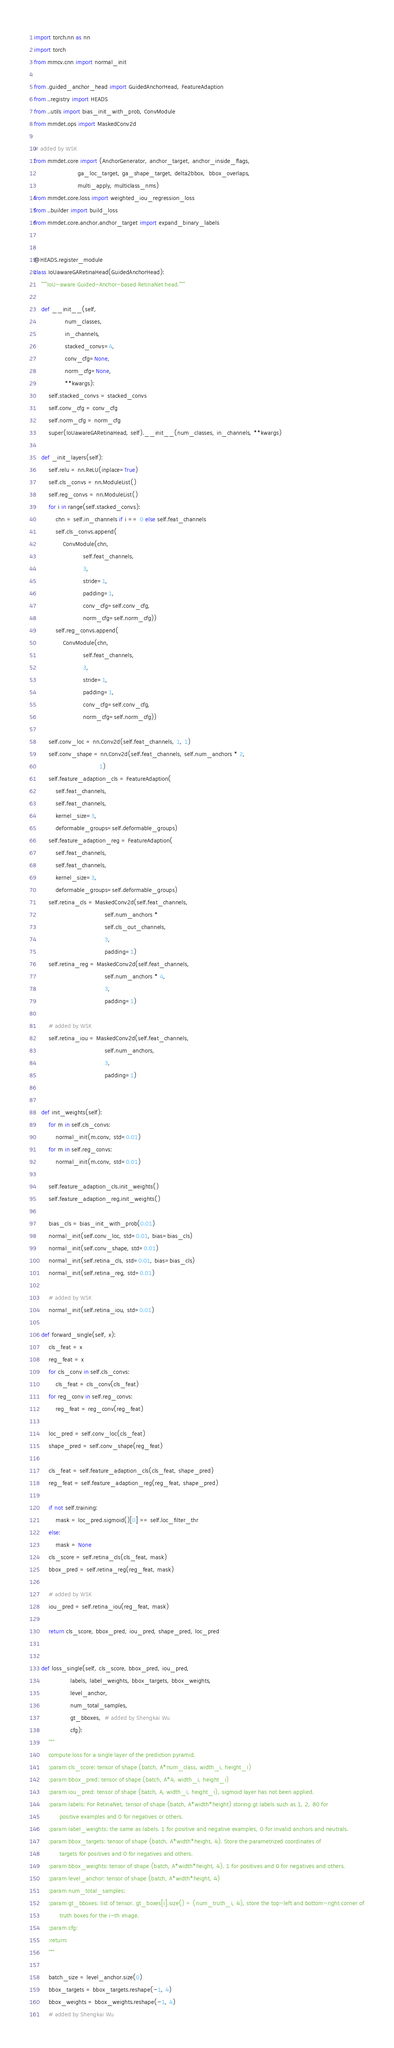<code> <loc_0><loc_0><loc_500><loc_500><_Python_>import torch.nn as nn
import torch
from mmcv.cnn import normal_init

from .guided_anchor_head import GuidedAnchorHead, FeatureAdaption
from ..registry import HEADS
from ..utils import bias_init_with_prob, ConvModule
from mmdet.ops import MaskedConv2d

# added by WSK
from mmdet.core import (AnchorGenerator, anchor_target, anchor_inside_flags,
                        ga_loc_target, ga_shape_target, delta2bbox,  bbox_overlaps,
                        multi_apply, multiclass_nms)
from mmdet.core.loss import weighted_iou_regression_loss
from ..builder import build_loss
from mmdet.core.anchor.anchor_target import expand_binary_labels


@HEADS.register_module
class IoUawareGARetinaHead(GuidedAnchorHead):
    """IoU-aware Guided-Anchor-based RetinaNet head."""

    def __init__(self,
                 num_classes,
                 in_channels,
                 stacked_convs=4,
                 conv_cfg=None,
                 norm_cfg=None,
                 **kwargs):
        self.stacked_convs = stacked_convs
        self.conv_cfg = conv_cfg
        self.norm_cfg = norm_cfg
        super(IoUawareGARetinaHead, self).__init__(num_classes, in_channels, **kwargs)

    def _init_layers(self):
        self.relu = nn.ReLU(inplace=True)
        self.cls_convs = nn.ModuleList()
        self.reg_convs = nn.ModuleList()
        for i in range(self.stacked_convs):
            chn = self.in_channels if i == 0 else self.feat_channels
            self.cls_convs.append(
                ConvModule(chn,
                           self.feat_channels,
                           3,
                           stride=1,
                           padding=1,
                           conv_cfg=self.conv_cfg,
                           norm_cfg=self.norm_cfg))
            self.reg_convs.append(
                ConvModule(chn,
                           self.feat_channels,
                           3,
                           stride=1,
                           padding=1,
                           conv_cfg=self.conv_cfg,
                           norm_cfg=self.norm_cfg))

        self.conv_loc = nn.Conv2d(self.feat_channels, 1, 1)
        self.conv_shape = nn.Conv2d(self.feat_channels, self.num_anchors * 2,
                                    1)
        self.feature_adaption_cls = FeatureAdaption(
            self.feat_channels,
            self.feat_channels,
            kernel_size=3,
            deformable_groups=self.deformable_groups)
        self.feature_adaption_reg = FeatureAdaption(
            self.feat_channels,
            self.feat_channels,
            kernel_size=3,
            deformable_groups=self.deformable_groups)
        self.retina_cls = MaskedConv2d(self.feat_channels,
                                       self.num_anchors *
                                       self.cls_out_channels,
                                       3,
                                       padding=1)
        self.retina_reg = MaskedConv2d(self.feat_channels,
                                       self.num_anchors * 4,
                                       3,
                                       padding=1)

        # added by WSK
        self.retina_iou = MaskedConv2d(self.feat_channels,
                                       self.num_anchors,
                                       3,
                                       padding=1)


    def init_weights(self):
        for m in self.cls_convs:
            normal_init(m.conv, std=0.01)
        for m in self.reg_convs:
            normal_init(m.conv, std=0.01)

        self.feature_adaption_cls.init_weights()
        self.feature_adaption_reg.init_weights()

        bias_cls = bias_init_with_prob(0.01)
        normal_init(self.conv_loc, std=0.01, bias=bias_cls)
        normal_init(self.conv_shape, std=0.01)
        normal_init(self.retina_cls, std=0.01, bias=bias_cls)
        normal_init(self.retina_reg, std=0.01)

        # added by WSK
        normal_init(self.retina_iou, std=0.01)

    def forward_single(self, x):
        cls_feat = x
        reg_feat = x
        for cls_conv in self.cls_convs:
            cls_feat = cls_conv(cls_feat)
        for reg_conv in self.reg_convs:
            reg_feat = reg_conv(reg_feat)

        loc_pred = self.conv_loc(cls_feat)
        shape_pred = self.conv_shape(reg_feat)

        cls_feat = self.feature_adaption_cls(cls_feat, shape_pred)
        reg_feat = self.feature_adaption_reg(reg_feat, shape_pred)

        if not self.training:
            mask = loc_pred.sigmoid()[0] >= self.loc_filter_thr
        else:
            mask = None
        cls_score = self.retina_cls(cls_feat, mask)
        bbox_pred = self.retina_reg(reg_feat, mask)

        # added by WSK
        iou_pred = self.retina_iou(reg_feat, mask)

        return cls_score, bbox_pred, iou_pred, shape_pred, loc_pred


    def loss_single(self, cls_score, bbox_pred, iou_pred,
                    labels, label_weights, bbox_targets, bbox_weights,
                    level_anchor,
                    num_total_samples,
                    gt_bboxes,  # added by Shengkai Wu
                    cfg):
        """
        compute loss for a single layer of the prediction pyramid.
        :param cls_score: tensor of shape (batch, A*num_class, width_i, height_i)
        :param bbox_pred: tensor of shape (batch, A*4, width_i, height_i)
        :param iou_pred: tensor of shape (batch, A, width_i, height_i), sigmoid layer has not been applied.
        :param labels: For RetinaNet, tensor of shape (batch, A*width*height) storing gt labels such as 1, 2, 80 for
              positive examples and 0 for negatives or others.
        :param label_weights: the same as labels. 1 for positive and negative examples, 0 for invalid anchors and neutrals.
        :param bbox_targets: tensor of shape (batch, A*width*height, 4). Store the parametrized coordinates of
              targets for positives and 0 for negatives and others.
        :param bbox_weights: tensor of shape (batch, A*width*height, 4). 1 for positives and 0 for negatives and others.
        :param level_anchor: tensor of shape (batch, A*width*height, 4)
        :param num_total_samples:
        :param gt_bboxes: list of tensor. gt_boxes[i].size() = (num_truth_i, 4), store the top-left and bottom-right corner of
              truth boxes for the i-th image.
        :param cfg:
        :return:
        """

        batch_size = level_anchor.size(0)
        bbox_targets = bbox_targets.reshape(-1, 4)
        bbox_weights = bbox_weights.reshape(-1, 4)
        # added by Shengkai Wu</code> 